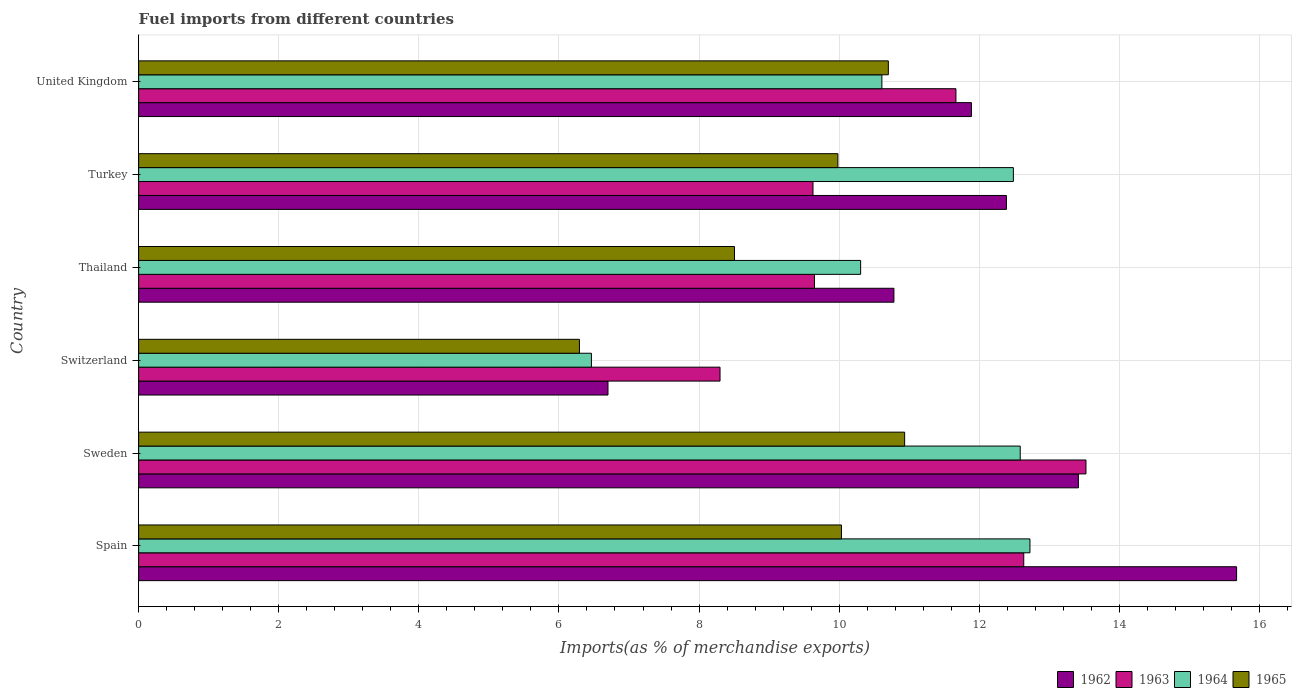How many bars are there on the 3rd tick from the top?
Provide a short and direct response. 4. How many bars are there on the 4th tick from the bottom?
Your answer should be very brief. 4. In how many cases, is the number of bars for a given country not equal to the number of legend labels?
Keep it short and to the point. 0. What is the percentage of imports to different countries in 1964 in United Kingdom?
Make the answer very short. 10.61. Across all countries, what is the maximum percentage of imports to different countries in 1962?
Make the answer very short. 15.67. Across all countries, what is the minimum percentage of imports to different countries in 1965?
Provide a succinct answer. 6.29. In which country was the percentage of imports to different countries in 1965 maximum?
Your response must be concise. Sweden. In which country was the percentage of imports to different countries in 1962 minimum?
Provide a short and direct response. Switzerland. What is the total percentage of imports to different countries in 1964 in the graph?
Your response must be concise. 65.18. What is the difference between the percentage of imports to different countries in 1963 in Spain and that in Turkey?
Ensure brevity in your answer.  3.01. What is the difference between the percentage of imports to different countries in 1963 in Thailand and the percentage of imports to different countries in 1964 in Spain?
Give a very brief answer. -3.08. What is the average percentage of imports to different countries in 1963 per country?
Give a very brief answer. 10.9. What is the difference between the percentage of imports to different countries in 1964 and percentage of imports to different countries in 1965 in Turkey?
Give a very brief answer. 2.51. In how many countries, is the percentage of imports to different countries in 1965 greater than 6 %?
Your response must be concise. 6. What is the ratio of the percentage of imports to different countries in 1962 in Spain to that in Thailand?
Offer a terse response. 1.45. What is the difference between the highest and the second highest percentage of imports to different countries in 1965?
Ensure brevity in your answer.  0.23. What is the difference between the highest and the lowest percentage of imports to different countries in 1963?
Provide a short and direct response. 5.22. Is the sum of the percentage of imports to different countries in 1965 in Turkey and United Kingdom greater than the maximum percentage of imports to different countries in 1962 across all countries?
Provide a succinct answer. Yes. What does the 2nd bar from the top in Spain represents?
Make the answer very short. 1964. What does the 4th bar from the bottom in Spain represents?
Your response must be concise. 1965. How many countries are there in the graph?
Ensure brevity in your answer.  6. Does the graph contain any zero values?
Your answer should be very brief. No. Does the graph contain grids?
Your response must be concise. Yes. How many legend labels are there?
Your answer should be very brief. 4. What is the title of the graph?
Give a very brief answer. Fuel imports from different countries. What is the label or title of the X-axis?
Your response must be concise. Imports(as % of merchandise exports). What is the label or title of the Y-axis?
Offer a terse response. Country. What is the Imports(as % of merchandise exports) of 1962 in Spain?
Give a very brief answer. 15.67. What is the Imports(as % of merchandise exports) in 1963 in Spain?
Keep it short and to the point. 12.64. What is the Imports(as % of merchandise exports) of 1964 in Spain?
Your answer should be compact. 12.72. What is the Imports(as % of merchandise exports) of 1965 in Spain?
Give a very brief answer. 10.03. What is the Imports(as % of merchandise exports) of 1962 in Sweden?
Ensure brevity in your answer.  13.42. What is the Imports(as % of merchandise exports) in 1963 in Sweden?
Ensure brevity in your answer.  13.52. What is the Imports(as % of merchandise exports) in 1964 in Sweden?
Keep it short and to the point. 12.58. What is the Imports(as % of merchandise exports) in 1965 in Sweden?
Offer a terse response. 10.93. What is the Imports(as % of merchandise exports) of 1962 in Switzerland?
Offer a terse response. 6.7. What is the Imports(as % of merchandise exports) in 1963 in Switzerland?
Provide a short and direct response. 8.3. What is the Imports(as % of merchandise exports) of 1964 in Switzerland?
Make the answer very short. 6.46. What is the Imports(as % of merchandise exports) of 1965 in Switzerland?
Your answer should be very brief. 6.29. What is the Imports(as % of merchandise exports) of 1962 in Thailand?
Your answer should be very brief. 10.78. What is the Imports(as % of merchandise exports) in 1963 in Thailand?
Make the answer very short. 9.65. What is the Imports(as % of merchandise exports) in 1964 in Thailand?
Provide a short and direct response. 10.31. What is the Imports(as % of merchandise exports) of 1965 in Thailand?
Provide a succinct answer. 8.51. What is the Imports(as % of merchandise exports) of 1962 in Turkey?
Ensure brevity in your answer.  12.39. What is the Imports(as % of merchandise exports) of 1963 in Turkey?
Make the answer very short. 9.63. What is the Imports(as % of merchandise exports) of 1964 in Turkey?
Keep it short and to the point. 12.49. What is the Imports(as % of merchandise exports) in 1965 in Turkey?
Offer a very short reply. 9.98. What is the Imports(as % of merchandise exports) of 1962 in United Kingdom?
Keep it short and to the point. 11.89. What is the Imports(as % of merchandise exports) in 1963 in United Kingdom?
Offer a very short reply. 11.67. What is the Imports(as % of merchandise exports) in 1964 in United Kingdom?
Offer a terse response. 10.61. What is the Imports(as % of merchandise exports) of 1965 in United Kingdom?
Keep it short and to the point. 10.7. Across all countries, what is the maximum Imports(as % of merchandise exports) in 1962?
Offer a very short reply. 15.67. Across all countries, what is the maximum Imports(as % of merchandise exports) in 1963?
Provide a succinct answer. 13.52. Across all countries, what is the maximum Imports(as % of merchandise exports) in 1964?
Offer a terse response. 12.72. Across all countries, what is the maximum Imports(as % of merchandise exports) in 1965?
Provide a short and direct response. 10.93. Across all countries, what is the minimum Imports(as % of merchandise exports) in 1962?
Give a very brief answer. 6.7. Across all countries, what is the minimum Imports(as % of merchandise exports) of 1963?
Make the answer very short. 8.3. Across all countries, what is the minimum Imports(as % of merchandise exports) in 1964?
Ensure brevity in your answer.  6.46. Across all countries, what is the minimum Imports(as % of merchandise exports) of 1965?
Ensure brevity in your answer.  6.29. What is the total Imports(as % of merchandise exports) in 1962 in the graph?
Give a very brief answer. 70.85. What is the total Imports(as % of merchandise exports) of 1963 in the graph?
Your response must be concise. 65.4. What is the total Imports(as % of merchandise exports) in 1964 in the graph?
Offer a very short reply. 65.18. What is the total Imports(as % of merchandise exports) of 1965 in the graph?
Give a very brief answer. 56.45. What is the difference between the Imports(as % of merchandise exports) of 1962 in Spain and that in Sweden?
Your answer should be compact. 2.26. What is the difference between the Imports(as % of merchandise exports) in 1963 in Spain and that in Sweden?
Ensure brevity in your answer.  -0.89. What is the difference between the Imports(as % of merchandise exports) of 1964 in Spain and that in Sweden?
Ensure brevity in your answer.  0.14. What is the difference between the Imports(as % of merchandise exports) of 1965 in Spain and that in Sweden?
Give a very brief answer. -0.9. What is the difference between the Imports(as % of merchandise exports) in 1962 in Spain and that in Switzerland?
Ensure brevity in your answer.  8.97. What is the difference between the Imports(as % of merchandise exports) in 1963 in Spain and that in Switzerland?
Offer a terse response. 4.34. What is the difference between the Imports(as % of merchandise exports) in 1964 in Spain and that in Switzerland?
Keep it short and to the point. 6.26. What is the difference between the Imports(as % of merchandise exports) of 1965 in Spain and that in Switzerland?
Provide a succinct answer. 3.74. What is the difference between the Imports(as % of merchandise exports) of 1962 in Spain and that in Thailand?
Keep it short and to the point. 4.89. What is the difference between the Imports(as % of merchandise exports) in 1963 in Spain and that in Thailand?
Keep it short and to the point. 2.99. What is the difference between the Imports(as % of merchandise exports) of 1964 in Spain and that in Thailand?
Make the answer very short. 2.42. What is the difference between the Imports(as % of merchandise exports) in 1965 in Spain and that in Thailand?
Provide a short and direct response. 1.53. What is the difference between the Imports(as % of merchandise exports) of 1962 in Spain and that in Turkey?
Provide a succinct answer. 3.29. What is the difference between the Imports(as % of merchandise exports) in 1963 in Spain and that in Turkey?
Ensure brevity in your answer.  3.01. What is the difference between the Imports(as % of merchandise exports) in 1964 in Spain and that in Turkey?
Provide a succinct answer. 0.24. What is the difference between the Imports(as % of merchandise exports) of 1965 in Spain and that in Turkey?
Provide a short and direct response. 0.05. What is the difference between the Imports(as % of merchandise exports) in 1962 in Spain and that in United Kingdom?
Provide a short and direct response. 3.79. What is the difference between the Imports(as % of merchandise exports) of 1963 in Spain and that in United Kingdom?
Your answer should be very brief. 0.97. What is the difference between the Imports(as % of merchandise exports) in 1964 in Spain and that in United Kingdom?
Keep it short and to the point. 2.11. What is the difference between the Imports(as % of merchandise exports) of 1965 in Spain and that in United Kingdom?
Provide a succinct answer. -0.67. What is the difference between the Imports(as % of merchandise exports) in 1962 in Sweden and that in Switzerland?
Provide a short and direct response. 6.72. What is the difference between the Imports(as % of merchandise exports) of 1963 in Sweden and that in Switzerland?
Ensure brevity in your answer.  5.22. What is the difference between the Imports(as % of merchandise exports) of 1964 in Sweden and that in Switzerland?
Your response must be concise. 6.12. What is the difference between the Imports(as % of merchandise exports) in 1965 in Sweden and that in Switzerland?
Provide a succinct answer. 4.64. What is the difference between the Imports(as % of merchandise exports) in 1962 in Sweden and that in Thailand?
Provide a short and direct response. 2.63. What is the difference between the Imports(as % of merchandise exports) in 1963 in Sweden and that in Thailand?
Ensure brevity in your answer.  3.88. What is the difference between the Imports(as % of merchandise exports) of 1964 in Sweden and that in Thailand?
Give a very brief answer. 2.28. What is the difference between the Imports(as % of merchandise exports) in 1965 in Sweden and that in Thailand?
Give a very brief answer. 2.43. What is the difference between the Imports(as % of merchandise exports) in 1962 in Sweden and that in Turkey?
Keep it short and to the point. 1.03. What is the difference between the Imports(as % of merchandise exports) in 1963 in Sweden and that in Turkey?
Offer a terse response. 3.9. What is the difference between the Imports(as % of merchandise exports) of 1964 in Sweden and that in Turkey?
Provide a succinct answer. 0.1. What is the difference between the Imports(as % of merchandise exports) in 1965 in Sweden and that in Turkey?
Your answer should be very brief. 0.95. What is the difference between the Imports(as % of merchandise exports) in 1962 in Sweden and that in United Kingdom?
Ensure brevity in your answer.  1.53. What is the difference between the Imports(as % of merchandise exports) in 1963 in Sweden and that in United Kingdom?
Provide a succinct answer. 1.86. What is the difference between the Imports(as % of merchandise exports) of 1964 in Sweden and that in United Kingdom?
Keep it short and to the point. 1.97. What is the difference between the Imports(as % of merchandise exports) in 1965 in Sweden and that in United Kingdom?
Give a very brief answer. 0.23. What is the difference between the Imports(as % of merchandise exports) of 1962 in Switzerland and that in Thailand?
Your response must be concise. -4.08. What is the difference between the Imports(as % of merchandise exports) of 1963 in Switzerland and that in Thailand?
Give a very brief answer. -1.35. What is the difference between the Imports(as % of merchandise exports) in 1964 in Switzerland and that in Thailand?
Ensure brevity in your answer.  -3.84. What is the difference between the Imports(as % of merchandise exports) in 1965 in Switzerland and that in Thailand?
Your answer should be very brief. -2.21. What is the difference between the Imports(as % of merchandise exports) in 1962 in Switzerland and that in Turkey?
Provide a short and direct response. -5.69. What is the difference between the Imports(as % of merchandise exports) in 1963 in Switzerland and that in Turkey?
Offer a terse response. -1.33. What is the difference between the Imports(as % of merchandise exports) of 1964 in Switzerland and that in Turkey?
Offer a terse response. -6.02. What is the difference between the Imports(as % of merchandise exports) of 1965 in Switzerland and that in Turkey?
Your response must be concise. -3.69. What is the difference between the Imports(as % of merchandise exports) in 1962 in Switzerland and that in United Kingdom?
Your answer should be very brief. -5.19. What is the difference between the Imports(as % of merchandise exports) in 1963 in Switzerland and that in United Kingdom?
Provide a succinct answer. -3.37. What is the difference between the Imports(as % of merchandise exports) of 1964 in Switzerland and that in United Kingdom?
Offer a very short reply. -4.15. What is the difference between the Imports(as % of merchandise exports) in 1965 in Switzerland and that in United Kingdom?
Provide a succinct answer. -4.41. What is the difference between the Imports(as % of merchandise exports) in 1962 in Thailand and that in Turkey?
Your answer should be compact. -1.61. What is the difference between the Imports(as % of merchandise exports) in 1963 in Thailand and that in Turkey?
Your answer should be compact. 0.02. What is the difference between the Imports(as % of merchandise exports) of 1964 in Thailand and that in Turkey?
Your answer should be very brief. -2.18. What is the difference between the Imports(as % of merchandise exports) of 1965 in Thailand and that in Turkey?
Give a very brief answer. -1.48. What is the difference between the Imports(as % of merchandise exports) of 1962 in Thailand and that in United Kingdom?
Offer a very short reply. -1.11. What is the difference between the Imports(as % of merchandise exports) of 1963 in Thailand and that in United Kingdom?
Provide a succinct answer. -2.02. What is the difference between the Imports(as % of merchandise exports) in 1964 in Thailand and that in United Kingdom?
Ensure brevity in your answer.  -0.3. What is the difference between the Imports(as % of merchandise exports) in 1965 in Thailand and that in United Kingdom?
Keep it short and to the point. -2.2. What is the difference between the Imports(as % of merchandise exports) in 1962 in Turkey and that in United Kingdom?
Give a very brief answer. 0.5. What is the difference between the Imports(as % of merchandise exports) of 1963 in Turkey and that in United Kingdom?
Give a very brief answer. -2.04. What is the difference between the Imports(as % of merchandise exports) in 1964 in Turkey and that in United Kingdom?
Give a very brief answer. 1.88. What is the difference between the Imports(as % of merchandise exports) in 1965 in Turkey and that in United Kingdom?
Offer a very short reply. -0.72. What is the difference between the Imports(as % of merchandise exports) in 1962 in Spain and the Imports(as % of merchandise exports) in 1963 in Sweden?
Your answer should be very brief. 2.15. What is the difference between the Imports(as % of merchandise exports) in 1962 in Spain and the Imports(as % of merchandise exports) in 1964 in Sweden?
Give a very brief answer. 3.09. What is the difference between the Imports(as % of merchandise exports) in 1962 in Spain and the Imports(as % of merchandise exports) in 1965 in Sweden?
Keep it short and to the point. 4.74. What is the difference between the Imports(as % of merchandise exports) of 1963 in Spain and the Imports(as % of merchandise exports) of 1964 in Sweden?
Ensure brevity in your answer.  0.05. What is the difference between the Imports(as % of merchandise exports) in 1963 in Spain and the Imports(as % of merchandise exports) in 1965 in Sweden?
Provide a short and direct response. 1.7. What is the difference between the Imports(as % of merchandise exports) of 1964 in Spain and the Imports(as % of merchandise exports) of 1965 in Sweden?
Give a very brief answer. 1.79. What is the difference between the Imports(as % of merchandise exports) of 1962 in Spain and the Imports(as % of merchandise exports) of 1963 in Switzerland?
Your answer should be very brief. 7.37. What is the difference between the Imports(as % of merchandise exports) in 1962 in Spain and the Imports(as % of merchandise exports) in 1964 in Switzerland?
Offer a terse response. 9.21. What is the difference between the Imports(as % of merchandise exports) in 1962 in Spain and the Imports(as % of merchandise exports) in 1965 in Switzerland?
Keep it short and to the point. 9.38. What is the difference between the Imports(as % of merchandise exports) in 1963 in Spain and the Imports(as % of merchandise exports) in 1964 in Switzerland?
Provide a short and direct response. 6.17. What is the difference between the Imports(as % of merchandise exports) in 1963 in Spain and the Imports(as % of merchandise exports) in 1965 in Switzerland?
Your answer should be compact. 6.34. What is the difference between the Imports(as % of merchandise exports) in 1964 in Spain and the Imports(as % of merchandise exports) in 1965 in Switzerland?
Give a very brief answer. 6.43. What is the difference between the Imports(as % of merchandise exports) in 1962 in Spain and the Imports(as % of merchandise exports) in 1963 in Thailand?
Ensure brevity in your answer.  6.03. What is the difference between the Imports(as % of merchandise exports) of 1962 in Spain and the Imports(as % of merchandise exports) of 1964 in Thailand?
Provide a short and direct response. 5.37. What is the difference between the Imports(as % of merchandise exports) in 1962 in Spain and the Imports(as % of merchandise exports) in 1965 in Thailand?
Your answer should be very brief. 7.17. What is the difference between the Imports(as % of merchandise exports) in 1963 in Spain and the Imports(as % of merchandise exports) in 1964 in Thailand?
Make the answer very short. 2.33. What is the difference between the Imports(as % of merchandise exports) in 1963 in Spain and the Imports(as % of merchandise exports) in 1965 in Thailand?
Your answer should be compact. 4.13. What is the difference between the Imports(as % of merchandise exports) in 1964 in Spain and the Imports(as % of merchandise exports) in 1965 in Thailand?
Provide a succinct answer. 4.22. What is the difference between the Imports(as % of merchandise exports) of 1962 in Spain and the Imports(as % of merchandise exports) of 1963 in Turkey?
Offer a very short reply. 6.05. What is the difference between the Imports(as % of merchandise exports) in 1962 in Spain and the Imports(as % of merchandise exports) in 1964 in Turkey?
Keep it short and to the point. 3.19. What is the difference between the Imports(as % of merchandise exports) of 1962 in Spain and the Imports(as % of merchandise exports) of 1965 in Turkey?
Your answer should be very brief. 5.69. What is the difference between the Imports(as % of merchandise exports) in 1963 in Spain and the Imports(as % of merchandise exports) in 1964 in Turkey?
Provide a short and direct response. 0.15. What is the difference between the Imports(as % of merchandise exports) of 1963 in Spain and the Imports(as % of merchandise exports) of 1965 in Turkey?
Your response must be concise. 2.65. What is the difference between the Imports(as % of merchandise exports) in 1964 in Spain and the Imports(as % of merchandise exports) in 1965 in Turkey?
Your response must be concise. 2.74. What is the difference between the Imports(as % of merchandise exports) of 1962 in Spain and the Imports(as % of merchandise exports) of 1963 in United Kingdom?
Make the answer very short. 4.01. What is the difference between the Imports(as % of merchandise exports) of 1962 in Spain and the Imports(as % of merchandise exports) of 1964 in United Kingdom?
Keep it short and to the point. 5.06. What is the difference between the Imports(as % of merchandise exports) in 1962 in Spain and the Imports(as % of merchandise exports) in 1965 in United Kingdom?
Your answer should be very brief. 4.97. What is the difference between the Imports(as % of merchandise exports) in 1963 in Spain and the Imports(as % of merchandise exports) in 1964 in United Kingdom?
Your answer should be compact. 2.03. What is the difference between the Imports(as % of merchandise exports) in 1963 in Spain and the Imports(as % of merchandise exports) in 1965 in United Kingdom?
Your answer should be compact. 1.93. What is the difference between the Imports(as % of merchandise exports) of 1964 in Spain and the Imports(as % of merchandise exports) of 1965 in United Kingdom?
Keep it short and to the point. 2.02. What is the difference between the Imports(as % of merchandise exports) of 1962 in Sweden and the Imports(as % of merchandise exports) of 1963 in Switzerland?
Make the answer very short. 5.12. What is the difference between the Imports(as % of merchandise exports) in 1962 in Sweden and the Imports(as % of merchandise exports) in 1964 in Switzerland?
Make the answer very short. 6.95. What is the difference between the Imports(as % of merchandise exports) of 1962 in Sweden and the Imports(as % of merchandise exports) of 1965 in Switzerland?
Keep it short and to the point. 7.12. What is the difference between the Imports(as % of merchandise exports) in 1963 in Sweden and the Imports(as % of merchandise exports) in 1964 in Switzerland?
Offer a very short reply. 7.06. What is the difference between the Imports(as % of merchandise exports) of 1963 in Sweden and the Imports(as % of merchandise exports) of 1965 in Switzerland?
Ensure brevity in your answer.  7.23. What is the difference between the Imports(as % of merchandise exports) in 1964 in Sweden and the Imports(as % of merchandise exports) in 1965 in Switzerland?
Ensure brevity in your answer.  6.29. What is the difference between the Imports(as % of merchandise exports) of 1962 in Sweden and the Imports(as % of merchandise exports) of 1963 in Thailand?
Offer a terse response. 3.77. What is the difference between the Imports(as % of merchandise exports) of 1962 in Sweden and the Imports(as % of merchandise exports) of 1964 in Thailand?
Your response must be concise. 3.11. What is the difference between the Imports(as % of merchandise exports) of 1962 in Sweden and the Imports(as % of merchandise exports) of 1965 in Thailand?
Provide a succinct answer. 4.91. What is the difference between the Imports(as % of merchandise exports) of 1963 in Sweden and the Imports(as % of merchandise exports) of 1964 in Thailand?
Offer a very short reply. 3.22. What is the difference between the Imports(as % of merchandise exports) of 1963 in Sweden and the Imports(as % of merchandise exports) of 1965 in Thailand?
Keep it short and to the point. 5.02. What is the difference between the Imports(as % of merchandise exports) of 1964 in Sweden and the Imports(as % of merchandise exports) of 1965 in Thailand?
Ensure brevity in your answer.  4.08. What is the difference between the Imports(as % of merchandise exports) of 1962 in Sweden and the Imports(as % of merchandise exports) of 1963 in Turkey?
Make the answer very short. 3.79. What is the difference between the Imports(as % of merchandise exports) of 1962 in Sweden and the Imports(as % of merchandise exports) of 1964 in Turkey?
Provide a short and direct response. 0.93. What is the difference between the Imports(as % of merchandise exports) in 1962 in Sweden and the Imports(as % of merchandise exports) in 1965 in Turkey?
Your answer should be compact. 3.43. What is the difference between the Imports(as % of merchandise exports) in 1963 in Sweden and the Imports(as % of merchandise exports) in 1964 in Turkey?
Make the answer very short. 1.04. What is the difference between the Imports(as % of merchandise exports) in 1963 in Sweden and the Imports(as % of merchandise exports) in 1965 in Turkey?
Make the answer very short. 3.54. What is the difference between the Imports(as % of merchandise exports) of 1964 in Sweden and the Imports(as % of merchandise exports) of 1965 in Turkey?
Offer a very short reply. 2.6. What is the difference between the Imports(as % of merchandise exports) of 1962 in Sweden and the Imports(as % of merchandise exports) of 1963 in United Kingdom?
Offer a very short reply. 1.75. What is the difference between the Imports(as % of merchandise exports) in 1962 in Sweden and the Imports(as % of merchandise exports) in 1964 in United Kingdom?
Give a very brief answer. 2.81. What is the difference between the Imports(as % of merchandise exports) of 1962 in Sweden and the Imports(as % of merchandise exports) of 1965 in United Kingdom?
Give a very brief answer. 2.71. What is the difference between the Imports(as % of merchandise exports) in 1963 in Sweden and the Imports(as % of merchandise exports) in 1964 in United Kingdom?
Your response must be concise. 2.91. What is the difference between the Imports(as % of merchandise exports) of 1963 in Sweden and the Imports(as % of merchandise exports) of 1965 in United Kingdom?
Provide a short and direct response. 2.82. What is the difference between the Imports(as % of merchandise exports) of 1964 in Sweden and the Imports(as % of merchandise exports) of 1965 in United Kingdom?
Offer a very short reply. 1.88. What is the difference between the Imports(as % of merchandise exports) of 1962 in Switzerland and the Imports(as % of merchandise exports) of 1963 in Thailand?
Keep it short and to the point. -2.95. What is the difference between the Imports(as % of merchandise exports) of 1962 in Switzerland and the Imports(as % of merchandise exports) of 1964 in Thailand?
Give a very brief answer. -3.61. What is the difference between the Imports(as % of merchandise exports) in 1962 in Switzerland and the Imports(as % of merchandise exports) in 1965 in Thailand?
Provide a short and direct response. -1.81. What is the difference between the Imports(as % of merchandise exports) in 1963 in Switzerland and the Imports(as % of merchandise exports) in 1964 in Thailand?
Make the answer very short. -2.01. What is the difference between the Imports(as % of merchandise exports) of 1963 in Switzerland and the Imports(as % of merchandise exports) of 1965 in Thailand?
Provide a succinct answer. -0.21. What is the difference between the Imports(as % of merchandise exports) in 1964 in Switzerland and the Imports(as % of merchandise exports) in 1965 in Thailand?
Make the answer very short. -2.04. What is the difference between the Imports(as % of merchandise exports) in 1962 in Switzerland and the Imports(as % of merchandise exports) in 1963 in Turkey?
Give a very brief answer. -2.93. What is the difference between the Imports(as % of merchandise exports) in 1962 in Switzerland and the Imports(as % of merchandise exports) in 1964 in Turkey?
Your answer should be compact. -5.79. What is the difference between the Imports(as % of merchandise exports) of 1962 in Switzerland and the Imports(as % of merchandise exports) of 1965 in Turkey?
Ensure brevity in your answer.  -3.28. What is the difference between the Imports(as % of merchandise exports) of 1963 in Switzerland and the Imports(as % of merchandise exports) of 1964 in Turkey?
Your answer should be very brief. -4.19. What is the difference between the Imports(as % of merchandise exports) in 1963 in Switzerland and the Imports(as % of merchandise exports) in 1965 in Turkey?
Offer a terse response. -1.68. What is the difference between the Imports(as % of merchandise exports) in 1964 in Switzerland and the Imports(as % of merchandise exports) in 1965 in Turkey?
Keep it short and to the point. -3.52. What is the difference between the Imports(as % of merchandise exports) in 1962 in Switzerland and the Imports(as % of merchandise exports) in 1963 in United Kingdom?
Give a very brief answer. -4.97. What is the difference between the Imports(as % of merchandise exports) of 1962 in Switzerland and the Imports(as % of merchandise exports) of 1964 in United Kingdom?
Provide a short and direct response. -3.91. What is the difference between the Imports(as % of merchandise exports) in 1962 in Switzerland and the Imports(as % of merchandise exports) in 1965 in United Kingdom?
Your answer should be compact. -4. What is the difference between the Imports(as % of merchandise exports) in 1963 in Switzerland and the Imports(as % of merchandise exports) in 1964 in United Kingdom?
Provide a short and direct response. -2.31. What is the difference between the Imports(as % of merchandise exports) of 1963 in Switzerland and the Imports(as % of merchandise exports) of 1965 in United Kingdom?
Make the answer very short. -2.4. What is the difference between the Imports(as % of merchandise exports) in 1964 in Switzerland and the Imports(as % of merchandise exports) in 1965 in United Kingdom?
Provide a short and direct response. -4.24. What is the difference between the Imports(as % of merchandise exports) of 1962 in Thailand and the Imports(as % of merchandise exports) of 1963 in Turkey?
Give a very brief answer. 1.16. What is the difference between the Imports(as % of merchandise exports) of 1962 in Thailand and the Imports(as % of merchandise exports) of 1964 in Turkey?
Ensure brevity in your answer.  -1.71. What is the difference between the Imports(as % of merchandise exports) in 1963 in Thailand and the Imports(as % of merchandise exports) in 1964 in Turkey?
Your response must be concise. -2.84. What is the difference between the Imports(as % of merchandise exports) in 1963 in Thailand and the Imports(as % of merchandise exports) in 1965 in Turkey?
Offer a terse response. -0.33. What is the difference between the Imports(as % of merchandise exports) of 1964 in Thailand and the Imports(as % of merchandise exports) of 1965 in Turkey?
Offer a very short reply. 0.32. What is the difference between the Imports(as % of merchandise exports) of 1962 in Thailand and the Imports(as % of merchandise exports) of 1963 in United Kingdom?
Keep it short and to the point. -0.89. What is the difference between the Imports(as % of merchandise exports) of 1962 in Thailand and the Imports(as % of merchandise exports) of 1964 in United Kingdom?
Your response must be concise. 0.17. What is the difference between the Imports(as % of merchandise exports) in 1962 in Thailand and the Imports(as % of merchandise exports) in 1965 in United Kingdom?
Provide a succinct answer. 0.08. What is the difference between the Imports(as % of merchandise exports) of 1963 in Thailand and the Imports(as % of merchandise exports) of 1964 in United Kingdom?
Make the answer very short. -0.96. What is the difference between the Imports(as % of merchandise exports) in 1963 in Thailand and the Imports(as % of merchandise exports) in 1965 in United Kingdom?
Your response must be concise. -1.05. What is the difference between the Imports(as % of merchandise exports) in 1964 in Thailand and the Imports(as % of merchandise exports) in 1965 in United Kingdom?
Your answer should be compact. -0.4. What is the difference between the Imports(as % of merchandise exports) in 1962 in Turkey and the Imports(as % of merchandise exports) in 1963 in United Kingdom?
Ensure brevity in your answer.  0.72. What is the difference between the Imports(as % of merchandise exports) of 1962 in Turkey and the Imports(as % of merchandise exports) of 1964 in United Kingdom?
Offer a terse response. 1.78. What is the difference between the Imports(as % of merchandise exports) of 1962 in Turkey and the Imports(as % of merchandise exports) of 1965 in United Kingdom?
Keep it short and to the point. 1.69. What is the difference between the Imports(as % of merchandise exports) in 1963 in Turkey and the Imports(as % of merchandise exports) in 1964 in United Kingdom?
Ensure brevity in your answer.  -0.98. What is the difference between the Imports(as % of merchandise exports) in 1963 in Turkey and the Imports(as % of merchandise exports) in 1965 in United Kingdom?
Your answer should be very brief. -1.08. What is the difference between the Imports(as % of merchandise exports) of 1964 in Turkey and the Imports(as % of merchandise exports) of 1965 in United Kingdom?
Offer a terse response. 1.78. What is the average Imports(as % of merchandise exports) of 1962 per country?
Provide a succinct answer. 11.81. What is the average Imports(as % of merchandise exports) in 1964 per country?
Make the answer very short. 10.86. What is the average Imports(as % of merchandise exports) in 1965 per country?
Offer a very short reply. 9.41. What is the difference between the Imports(as % of merchandise exports) in 1962 and Imports(as % of merchandise exports) in 1963 in Spain?
Provide a short and direct response. 3.04. What is the difference between the Imports(as % of merchandise exports) of 1962 and Imports(as % of merchandise exports) of 1964 in Spain?
Your answer should be compact. 2.95. What is the difference between the Imports(as % of merchandise exports) in 1962 and Imports(as % of merchandise exports) in 1965 in Spain?
Offer a terse response. 5.64. What is the difference between the Imports(as % of merchandise exports) of 1963 and Imports(as % of merchandise exports) of 1964 in Spain?
Give a very brief answer. -0.09. What is the difference between the Imports(as % of merchandise exports) of 1963 and Imports(as % of merchandise exports) of 1965 in Spain?
Offer a very short reply. 2.6. What is the difference between the Imports(as % of merchandise exports) in 1964 and Imports(as % of merchandise exports) in 1965 in Spain?
Offer a very short reply. 2.69. What is the difference between the Imports(as % of merchandise exports) of 1962 and Imports(as % of merchandise exports) of 1963 in Sweden?
Offer a very short reply. -0.11. What is the difference between the Imports(as % of merchandise exports) in 1962 and Imports(as % of merchandise exports) in 1964 in Sweden?
Your answer should be very brief. 0.83. What is the difference between the Imports(as % of merchandise exports) of 1962 and Imports(as % of merchandise exports) of 1965 in Sweden?
Make the answer very short. 2.48. What is the difference between the Imports(as % of merchandise exports) of 1963 and Imports(as % of merchandise exports) of 1964 in Sweden?
Your response must be concise. 0.94. What is the difference between the Imports(as % of merchandise exports) of 1963 and Imports(as % of merchandise exports) of 1965 in Sweden?
Ensure brevity in your answer.  2.59. What is the difference between the Imports(as % of merchandise exports) in 1964 and Imports(as % of merchandise exports) in 1965 in Sweden?
Offer a terse response. 1.65. What is the difference between the Imports(as % of merchandise exports) in 1962 and Imports(as % of merchandise exports) in 1963 in Switzerland?
Give a very brief answer. -1.6. What is the difference between the Imports(as % of merchandise exports) in 1962 and Imports(as % of merchandise exports) in 1964 in Switzerland?
Offer a very short reply. 0.24. What is the difference between the Imports(as % of merchandise exports) in 1962 and Imports(as % of merchandise exports) in 1965 in Switzerland?
Keep it short and to the point. 0.41. What is the difference between the Imports(as % of merchandise exports) in 1963 and Imports(as % of merchandise exports) in 1964 in Switzerland?
Your answer should be very brief. 1.84. What is the difference between the Imports(as % of merchandise exports) in 1963 and Imports(as % of merchandise exports) in 1965 in Switzerland?
Make the answer very short. 2.01. What is the difference between the Imports(as % of merchandise exports) of 1964 and Imports(as % of merchandise exports) of 1965 in Switzerland?
Your answer should be very brief. 0.17. What is the difference between the Imports(as % of merchandise exports) in 1962 and Imports(as % of merchandise exports) in 1963 in Thailand?
Provide a succinct answer. 1.13. What is the difference between the Imports(as % of merchandise exports) of 1962 and Imports(as % of merchandise exports) of 1964 in Thailand?
Make the answer very short. 0.48. What is the difference between the Imports(as % of merchandise exports) of 1962 and Imports(as % of merchandise exports) of 1965 in Thailand?
Make the answer very short. 2.28. What is the difference between the Imports(as % of merchandise exports) of 1963 and Imports(as % of merchandise exports) of 1964 in Thailand?
Make the answer very short. -0.66. What is the difference between the Imports(as % of merchandise exports) of 1963 and Imports(as % of merchandise exports) of 1965 in Thailand?
Provide a short and direct response. 1.14. What is the difference between the Imports(as % of merchandise exports) in 1964 and Imports(as % of merchandise exports) in 1965 in Thailand?
Make the answer very short. 1.8. What is the difference between the Imports(as % of merchandise exports) of 1962 and Imports(as % of merchandise exports) of 1963 in Turkey?
Your answer should be compact. 2.76. What is the difference between the Imports(as % of merchandise exports) of 1962 and Imports(as % of merchandise exports) of 1964 in Turkey?
Ensure brevity in your answer.  -0.1. What is the difference between the Imports(as % of merchandise exports) of 1962 and Imports(as % of merchandise exports) of 1965 in Turkey?
Provide a short and direct response. 2.41. What is the difference between the Imports(as % of merchandise exports) in 1963 and Imports(as % of merchandise exports) in 1964 in Turkey?
Provide a short and direct response. -2.86. What is the difference between the Imports(as % of merchandise exports) in 1963 and Imports(as % of merchandise exports) in 1965 in Turkey?
Your answer should be very brief. -0.36. What is the difference between the Imports(as % of merchandise exports) in 1964 and Imports(as % of merchandise exports) in 1965 in Turkey?
Ensure brevity in your answer.  2.51. What is the difference between the Imports(as % of merchandise exports) in 1962 and Imports(as % of merchandise exports) in 1963 in United Kingdom?
Offer a very short reply. 0.22. What is the difference between the Imports(as % of merchandise exports) of 1962 and Imports(as % of merchandise exports) of 1964 in United Kingdom?
Ensure brevity in your answer.  1.28. What is the difference between the Imports(as % of merchandise exports) of 1962 and Imports(as % of merchandise exports) of 1965 in United Kingdom?
Offer a terse response. 1.19. What is the difference between the Imports(as % of merchandise exports) of 1963 and Imports(as % of merchandise exports) of 1964 in United Kingdom?
Your answer should be very brief. 1.06. What is the difference between the Imports(as % of merchandise exports) in 1963 and Imports(as % of merchandise exports) in 1965 in United Kingdom?
Provide a short and direct response. 0.96. What is the difference between the Imports(as % of merchandise exports) of 1964 and Imports(as % of merchandise exports) of 1965 in United Kingdom?
Offer a very short reply. -0.09. What is the ratio of the Imports(as % of merchandise exports) of 1962 in Spain to that in Sweden?
Make the answer very short. 1.17. What is the ratio of the Imports(as % of merchandise exports) of 1963 in Spain to that in Sweden?
Keep it short and to the point. 0.93. What is the ratio of the Imports(as % of merchandise exports) in 1965 in Spain to that in Sweden?
Offer a very short reply. 0.92. What is the ratio of the Imports(as % of merchandise exports) of 1962 in Spain to that in Switzerland?
Your answer should be compact. 2.34. What is the ratio of the Imports(as % of merchandise exports) of 1963 in Spain to that in Switzerland?
Give a very brief answer. 1.52. What is the ratio of the Imports(as % of merchandise exports) of 1964 in Spain to that in Switzerland?
Provide a succinct answer. 1.97. What is the ratio of the Imports(as % of merchandise exports) of 1965 in Spain to that in Switzerland?
Give a very brief answer. 1.59. What is the ratio of the Imports(as % of merchandise exports) of 1962 in Spain to that in Thailand?
Offer a terse response. 1.45. What is the ratio of the Imports(as % of merchandise exports) of 1963 in Spain to that in Thailand?
Your response must be concise. 1.31. What is the ratio of the Imports(as % of merchandise exports) of 1964 in Spain to that in Thailand?
Provide a short and direct response. 1.23. What is the ratio of the Imports(as % of merchandise exports) in 1965 in Spain to that in Thailand?
Your response must be concise. 1.18. What is the ratio of the Imports(as % of merchandise exports) of 1962 in Spain to that in Turkey?
Provide a succinct answer. 1.27. What is the ratio of the Imports(as % of merchandise exports) of 1963 in Spain to that in Turkey?
Your answer should be compact. 1.31. What is the ratio of the Imports(as % of merchandise exports) of 1964 in Spain to that in Turkey?
Give a very brief answer. 1.02. What is the ratio of the Imports(as % of merchandise exports) of 1965 in Spain to that in Turkey?
Offer a terse response. 1.01. What is the ratio of the Imports(as % of merchandise exports) of 1962 in Spain to that in United Kingdom?
Offer a terse response. 1.32. What is the ratio of the Imports(as % of merchandise exports) of 1963 in Spain to that in United Kingdom?
Offer a very short reply. 1.08. What is the ratio of the Imports(as % of merchandise exports) of 1964 in Spain to that in United Kingdom?
Keep it short and to the point. 1.2. What is the ratio of the Imports(as % of merchandise exports) of 1965 in Spain to that in United Kingdom?
Keep it short and to the point. 0.94. What is the ratio of the Imports(as % of merchandise exports) in 1962 in Sweden to that in Switzerland?
Provide a succinct answer. 2. What is the ratio of the Imports(as % of merchandise exports) of 1963 in Sweden to that in Switzerland?
Your answer should be compact. 1.63. What is the ratio of the Imports(as % of merchandise exports) in 1964 in Sweden to that in Switzerland?
Make the answer very short. 1.95. What is the ratio of the Imports(as % of merchandise exports) in 1965 in Sweden to that in Switzerland?
Provide a short and direct response. 1.74. What is the ratio of the Imports(as % of merchandise exports) in 1962 in Sweden to that in Thailand?
Keep it short and to the point. 1.24. What is the ratio of the Imports(as % of merchandise exports) of 1963 in Sweden to that in Thailand?
Keep it short and to the point. 1.4. What is the ratio of the Imports(as % of merchandise exports) in 1964 in Sweden to that in Thailand?
Keep it short and to the point. 1.22. What is the ratio of the Imports(as % of merchandise exports) of 1965 in Sweden to that in Thailand?
Your answer should be very brief. 1.29. What is the ratio of the Imports(as % of merchandise exports) in 1962 in Sweden to that in Turkey?
Offer a very short reply. 1.08. What is the ratio of the Imports(as % of merchandise exports) in 1963 in Sweden to that in Turkey?
Ensure brevity in your answer.  1.4. What is the ratio of the Imports(as % of merchandise exports) of 1964 in Sweden to that in Turkey?
Your answer should be very brief. 1.01. What is the ratio of the Imports(as % of merchandise exports) in 1965 in Sweden to that in Turkey?
Your response must be concise. 1.1. What is the ratio of the Imports(as % of merchandise exports) in 1962 in Sweden to that in United Kingdom?
Make the answer very short. 1.13. What is the ratio of the Imports(as % of merchandise exports) of 1963 in Sweden to that in United Kingdom?
Keep it short and to the point. 1.16. What is the ratio of the Imports(as % of merchandise exports) of 1964 in Sweden to that in United Kingdom?
Make the answer very short. 1.19. What is the ratio of the Imports(as % of merchandise exports) of 1965 in Sweden to that in United Kingdom?
Your answer should be compact. 1.02. What is the ratio of the Imports(as % of merchandise exports) in 1962 in Switzerland to that in Thailand?
Give a very brief answer. 0.62. What is the ratio of the Imports(as % of merchandise exports) of 1963 in Switzerland to that in Thailand?
Your answer should be compact. 0.86. What is the ratio of the Imports(as % of merchandise exports) of 1964 in Switzerland to that in Thailand?
Offer a very short reply. 0.63. What is the ratio of the Imports(as % of merchandise exports) in 1965 in Switzerland to that in Thailand?
Your answer should be compact. 0.74. What is the ratio of the Imports(as % of merchandise exports) in 1962 in Switzerland to that in Turkey?
Your response must be concise. 0.54. What is the ratio of the Imports(as % of merchandise exports) of 1963 in Switzerland to that in Turkey?
Your answer should be compact. 0.86. What is the ratio of the Imports(as % of merchandise exports) in 1964 in Switzerland to that in Turkey?
Ensure brevity in your answer.  0.52. What is the ratio of the Imports(as % of merchandise exports) in 1965 in Switzerland to that in Turkey?
Offer a very short reply. 0.63. What is the ratio of the Imports(as % of merchandise exports) of 1962 in Switzerland to that in United Kingdom?
Provide a short and direct response. 0.56. What is the ratio of the Imports(as % of merchandise exports) in 1963 in Switzerland to that in United Kingdom?
Your answer should be compact. 0.71. What is the ratio of the Imports(as % of merchandise exports) in 1964 in Switzerland to that in United Kingdom?
Make the answer very short. 0.61. What is the ratio of the Imports(as % of merchandise exports) of 1965 in Switzerland to that in United Kingdom?
Make the answer very short. 0.59. What is the ratio of the Imports(as % of merchandise exports) of 1962 in Thailand to that in Turkey?
Provide a short and direct response. 0.87. What is the ratio of the Imports(as % of merchandise exports) in 1964 in Thailand to that in Turkey?
Keep it short and to the point. 0.83. What is the ratio of the Imports(as % of merchandise exports) of 1965 in Thailand to that in Turkey?
Your response must be concise. 0.85. What is the ratio of the Imports(as % of merchandise exports) of 1962 in Thailand to that in United Kingdom?
Ensure brevity in your answer.  0.91. What is the ratio of the Imports(as % of merchandise exports) of 1963 in Thailand to that in United Kingdom?
Provide a short and direct response. 0.83. What is the ratio of the Imports(as % of merchandise exports) in 1964 in Thailand to that in United Kingdom?
Offer a terse response. 0.97. What is the ratio of the Imports(as % of merchandise exports) of 1965 in Thailand to that in United Kingdom?
Offer a very short reply. 0.79. What is the ratio of the Imports(as % of merchandise exports) of 1962 in Turkey to that in United Kingdom?
Provide a succinct answer. 1.04. What is the ratio of the Imports(as % of merchandise exports) of 1963 in Turkey to that in United Kingdom?
Your answer should be compact. 0.83. What is the ratio of the Imports(as % of merchandise exports) in 1964 in Turkey to that in United Kingdom?
Make the answer very short. 1.18. What is the ratio of the Imports(as % of merchandise exports) in 1965 in Turkey to that in United Kingdom?
Ensure brevity in your answer.  0.93. What is the difference between the highest and the second highest Imports(as % of merchandise exports) of 1962?
Offer a terse response. 2.26. What is the difference between the highest and the second highest Imports(as % of merchandise exports) in 1963?
Ensure brevity in your answer.  0.89. What is the difference between the highest and the second highest Imports(as % of merchandise exports) of 1964?
Your answer should be compact. 0.14. What is the difference between the highest and the second highest Imports(as % of merchandise exports) in 1965?
Make the answer very short. 0.23. What is the difference between the highest and the lowest Imports(as % of merchandise exports) of 1962?
Provide a succinct answer. 8.97. What is the difference between the highest and the lowest Imports(as % of merchandise exports) of 1963?
Your answer should be very brief. 5.22. What is the difference between the highest and the lowest Imports(as % of merchandise exports) in 1964?
Your response must be concise. 6.26. What is the difference between the highest and the lowest Imports(as % of merchandise exports) of 1965?
Provide a succinct answer. 4.64. 